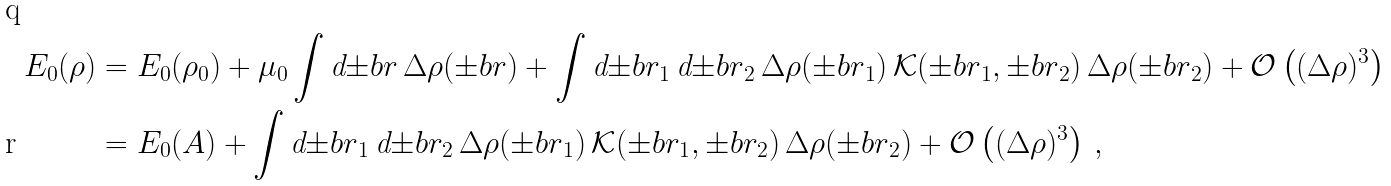<formula> <loc_0><loc_0><loc_500><loc_500>E _ { 0 } ( \rho ) & = E _ { 0 } ( \rho _ { 0 } ) + \mu _ { 0 } \int \text {d} { \pm b r } \, \Delta \rho ( { \pm b r } ) + \int \text {d} { \pm b r } _ { 1 } \, \text {d} { \pm b r } _ { 2 } \, \Delta \rho ( { \pm b r } _ { 1 } ) \, { \mathcal { K } } ( { \pm b r } _ { 1 } , { \pm b r } _ { 2 } ) \, \Delta \rho ( { \pm b r } _ { 2 } ) + { \mathcal { O } } \left ( ( \Delta \rho ) ^ { 3 } \right ) \\ & = E _ { 0 } ( A ) + \int \text {d} { \pm b r } _ { 1 } \, \text {d} { \pm b r } _ { 2 } \, \Delta \rho ( { \pm b r } _ { 1 } ) \, { \mathcal { K } } ( { \pm b r } _ { 1 } , { \pm b r } _ { 2 } ) \, \Delta \rho ( { \pm b r } _ { 2 } ) + { \mathcal { O } } \left ( ( \Delta \rho ) ^ { 3 } \right ) \, ,</formula> 